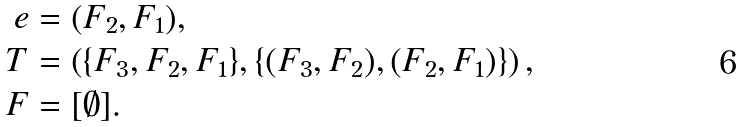<formula> <loc_0><loc_0><loc_500><loc_500>e & = ( F _ { 2 } , F _ { 1 } ) , \\ T & = \left ( \{ F _ { 3 } , F _ { 2 } , F _ { 1 } \} , \{ ( F _ { 3 } , F _ { 2 } ) , ( F _ { 2 } , F _ { 1 } ) \} \right ) , \\ F & = [ \emptyset ] .</formula> 